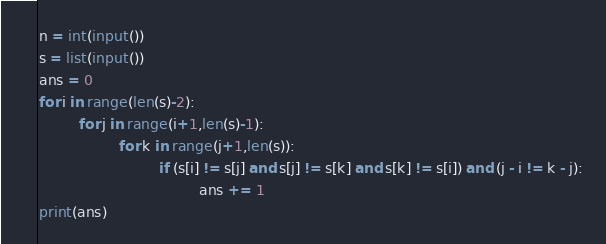<code> <loc_0><loc_0><loc_500><loc_500><_Python_>n = int(input())
s = list(input())
ans = 0
for i in range(len(s)-2):
         for j in range(i+1,len(s)-1):
                  for k in range(j+1,len(s)):
                           if (s[i] != s[j] and s[j] != s[k] and s[k] != s[i]) and (j - i != k - j):
                                    ans += 1
print(ans)
</code> 